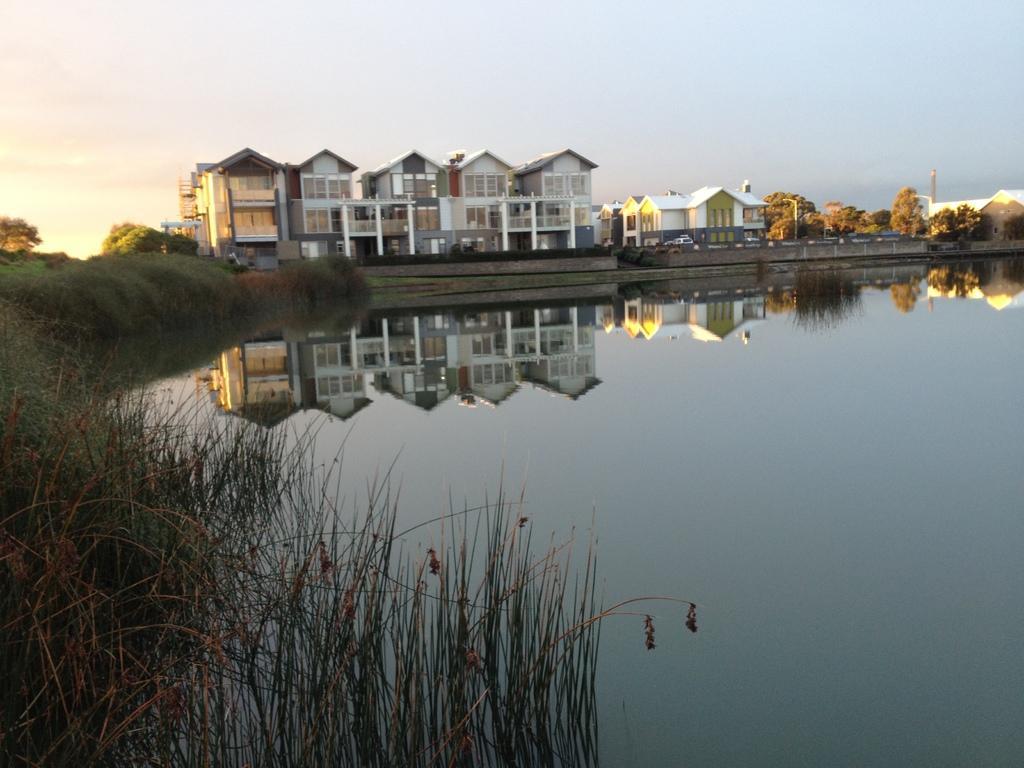In one or two sentences, can you explain what this image depicts? In the foreground of the picture there are grass, weed and water. In the center of the picture there are trees, buildings, vehicles and poles. Sky is clear. 